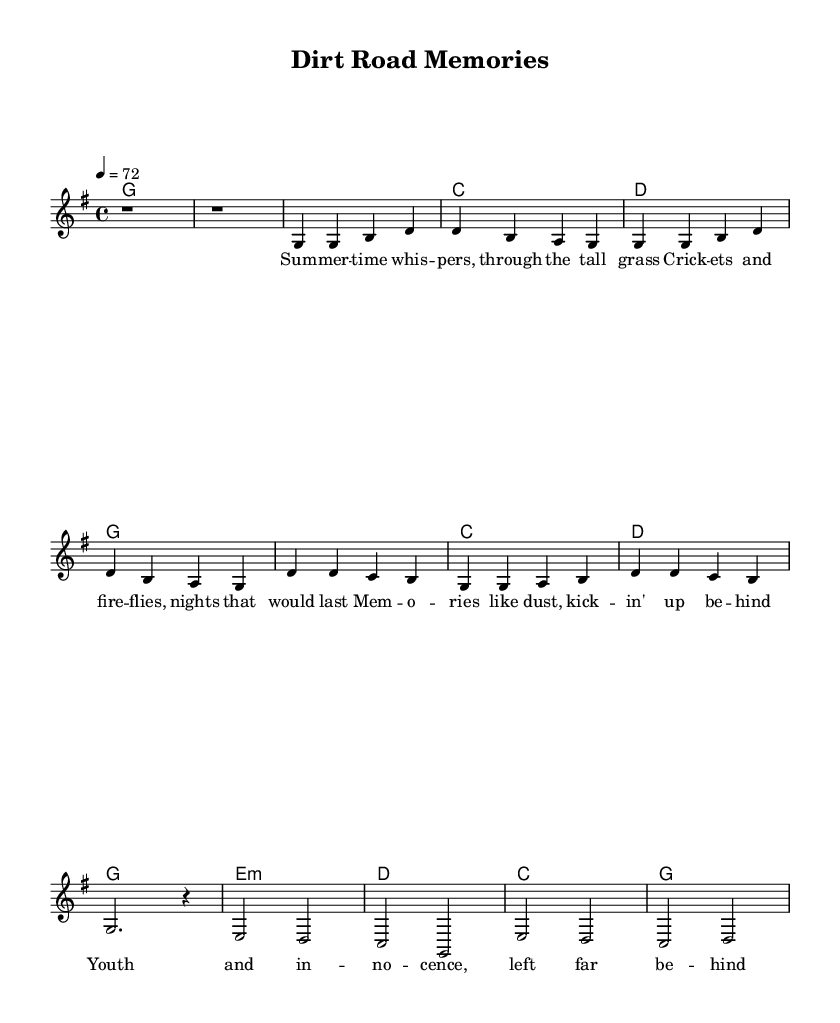What is the key signature of this music? The key signature is G major, which has one sharp (F#).
Answer: G major What is the time signature of this piece? The time signature is 4/4, meaning there are four beats in each measure and the quarter note receives one beat.
Answer: 4/4 What is the tempo marking of this score? The tempo marking is 72 beats per minute, indicating how fast the piece should be played.
Answer: 72 How many measures are in the verse? The verse consists of four measures as indicated by the four sets of notes in the verse section.
Answer: Four measures Which chord progression is used in the chorus? The chorus follows the chord progression G, C, D, G, which can be identified in the harmonies section.
Answer: G, C, D, G What is a recurring lyrical motif in this ballad? The line “Memories like dust” is a recurring lyrical motif present in the chorus of the song, emphasizing nostalgia.
Answer: Memories like dust Why is the bridge section important in this structure? The bridge typically provides contrast and emotional depth in a ballad, which can be seen in this piece as it shifts to different chords and pitches from the verse and chorus.
Answer: Contrast and emotional depth 